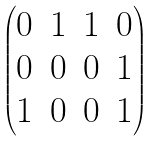Convert formula to latex. <formula><loc_0><loc_0><loc_500><loc_500>\begin{pmatrix} 0 & 1 & 1 & 0 \\ 0 & 0 & 0 & 1 \\ 1 & 0 & 0 & 1 \end{pmatrix}</formula> 